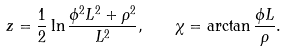<formula> <loc_0><loc_0><loc_500><loc_500>z = \frac { 1 } { 2 } \ln \frac { \phi ^ { 2 } L ^ { 2 } + \rho ^ { 2 } } { L ^ { 2 } } , \quad \chi = \arctan \frac { \phi L } { \rho } .</formula> 